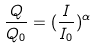<formula> <loc_0><loc_0><loc_500><loc_500>\frac { Q } { Q _ { 0 } } = ( \frac { I } { I _ { 0 } } ) ^ { \alpha }</formula> 